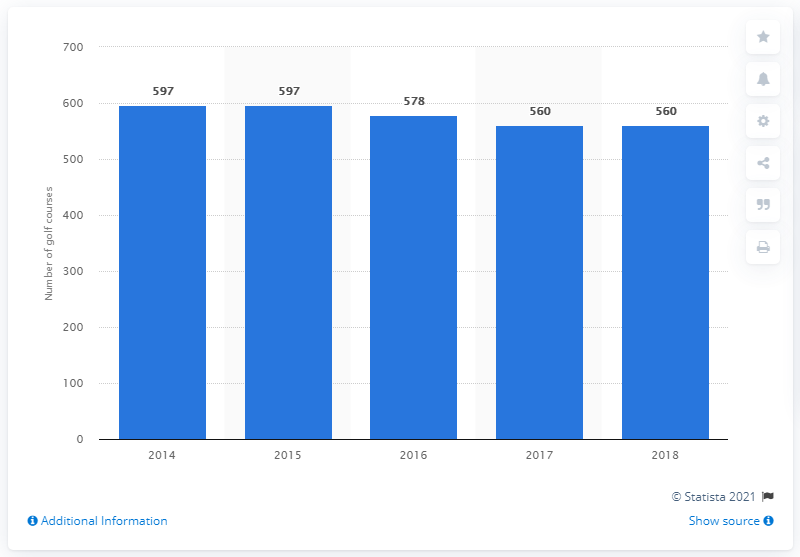How significant are these numbers relative to the worldwide context? Scotland's 560 golf courses in 2018 represent a substantial concentration of golf courses given its size, showcasing its status as a premier golfing destination. Globally, Scotland's courses are renowned and are an essential part of its tourism industry, attracting golf enthusiasts from all over the world. 